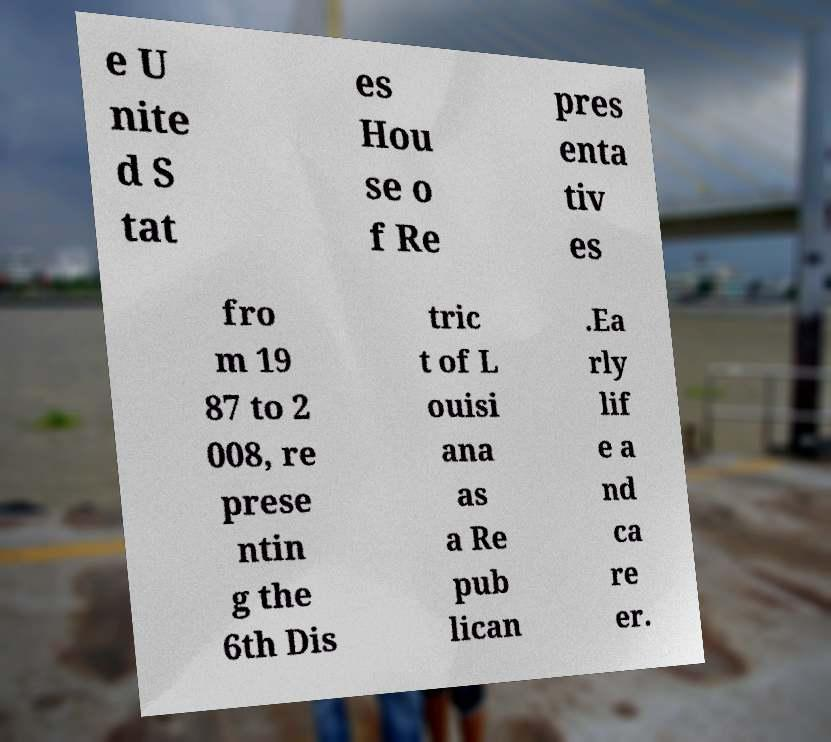Can you accurately transcribe the text from the provided image for me? e U nite d S tat es Hou se o f Re pres enta tiv es fro m 19 87 to 2 008, re prese ntin g the 6th Dis tric t of L ouisi ana as a Re pub lican .Ea rly lif e a nd ca re er. 